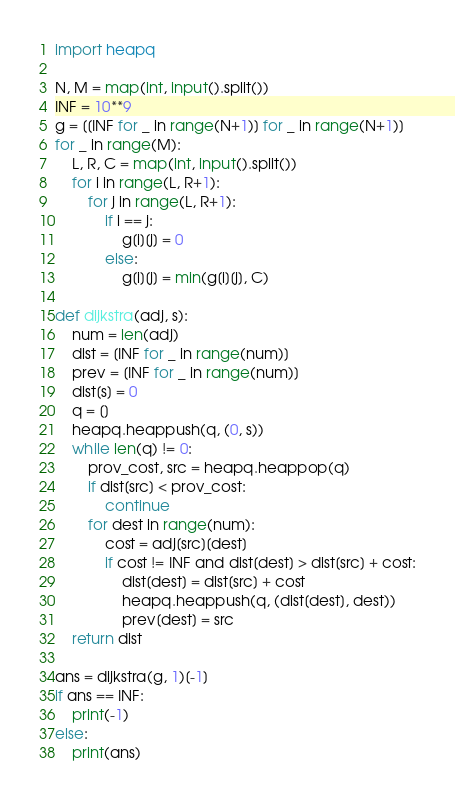Convert code to text. <code><loc_0><loc_0><loc_500><loc_500><_Python_>import heapq

N, M = map(int, input().split())
INF = 10**9
g = [[INF for _ in range(N+1)] for _ in range(N+1)]
for _ in range(M):
    L, R, C = map(int, input().split())
    for i in range(L, R+1):
        for j in range(L, R+1):
            if i == j:
                g[i][j] = 0
            else:
                g[i][j] = min(g[i][j], C)

def dijkstra(adj, s):
    num = len(adj)
    dist = [INF for _ in range(num)]
    prev = [INF for _ in range(num)]
    dist[s] = 0
    q = []
    heapq.heappush(q, (0, s))
    while len(q) != 0:
        prov_cost, src = heapq.heappop(q)
        if dist[src] < prov_cost:
            continue
        for dest in range(num):
            cost = adj[src][dest]
            if cost != INF and dist[dest] > dist[src] + cost:
                dist[dest] = dist[src] + cost
                heapq.heappush(q, (dist[dest], dest))
                prev[dest] = src
    return dist

ans = dijkstra(g, 1)[-1]
if ans == INF:
    print(-1)
else:
    print(ans)</code> 